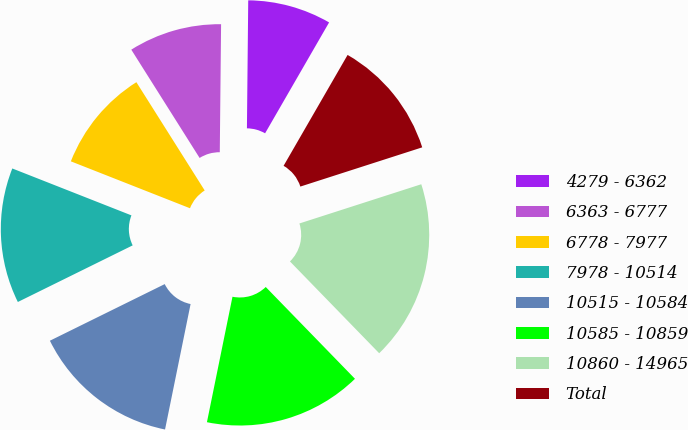Convert chart. <chart><loc_0><loc_0><loc_500><loc_500><pie_chart><fcel>4279 - 6362<fcel>6363 - 6777<fcel>6778 - 7977<fcel>7978 - 10514<fcel>10515 - 10584<fcel>10585 - 10859<fcel>10860 - 14965<fcel>Total<nl><fcel>8.17%<fcel>9.12%<fcel>10.07%<fcel>13.26%<fcel>14.51%<fcel>15.47%<fcel>17.68%<fcel>11.71%<nl></chart> 